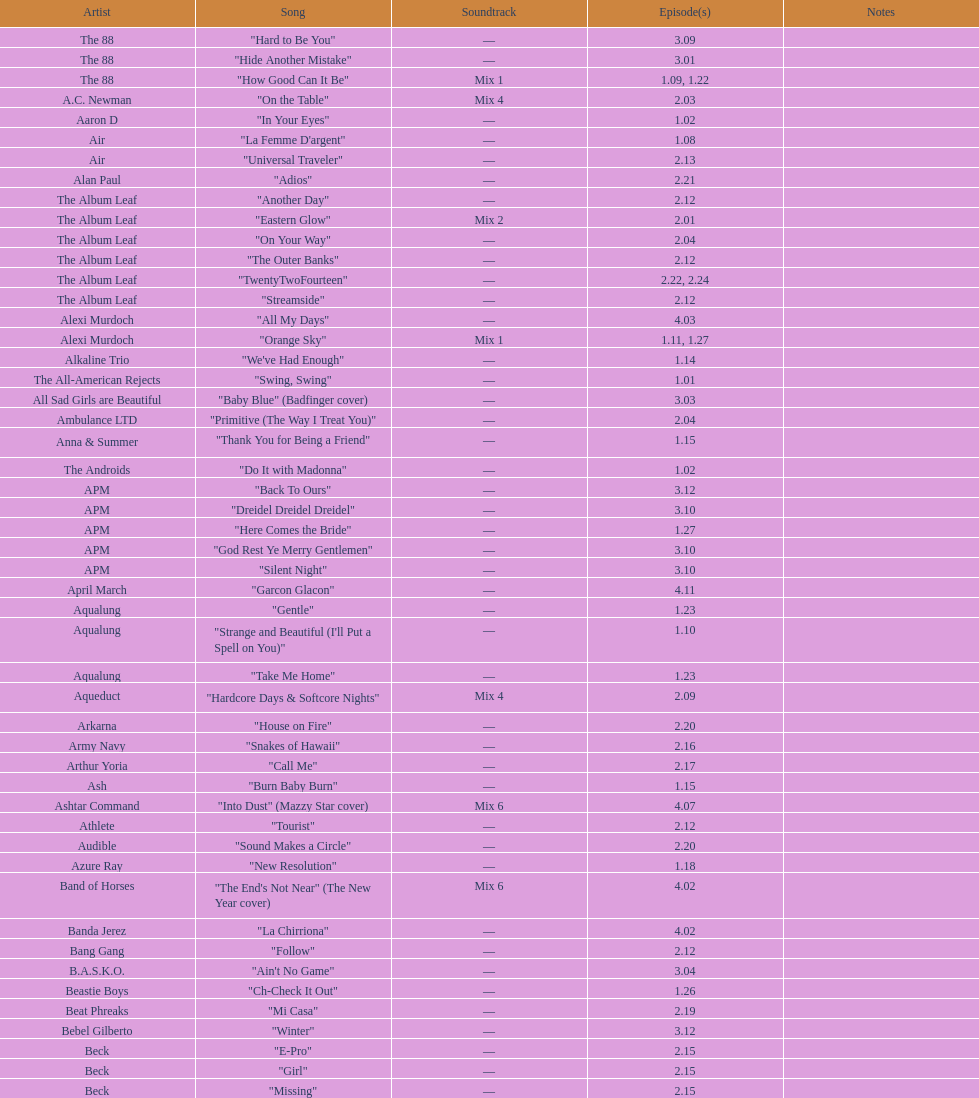How many consecutive songs were by the album leaf? 6. 